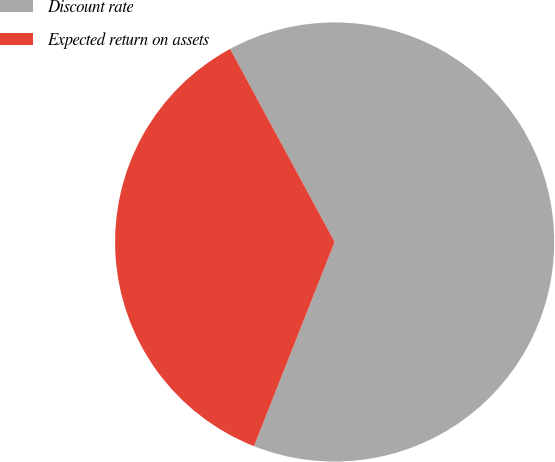Convert chart to OTSL. <chart><loc_0><loc_0><loc_500><loc_500><pie_chart><fcel>Discount rate<fcel>Expected return on assets<nl><fcel>63.89%<fcel>36.11%<nl></chart> 